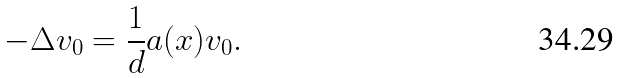Convert formula to latex. <formula><loc_0><loc_0><loc_500><loc_500>- \Delta v _ { 0 } = \frac { 1 } { d } a ( x ) v _ { 0 } .</formula> 